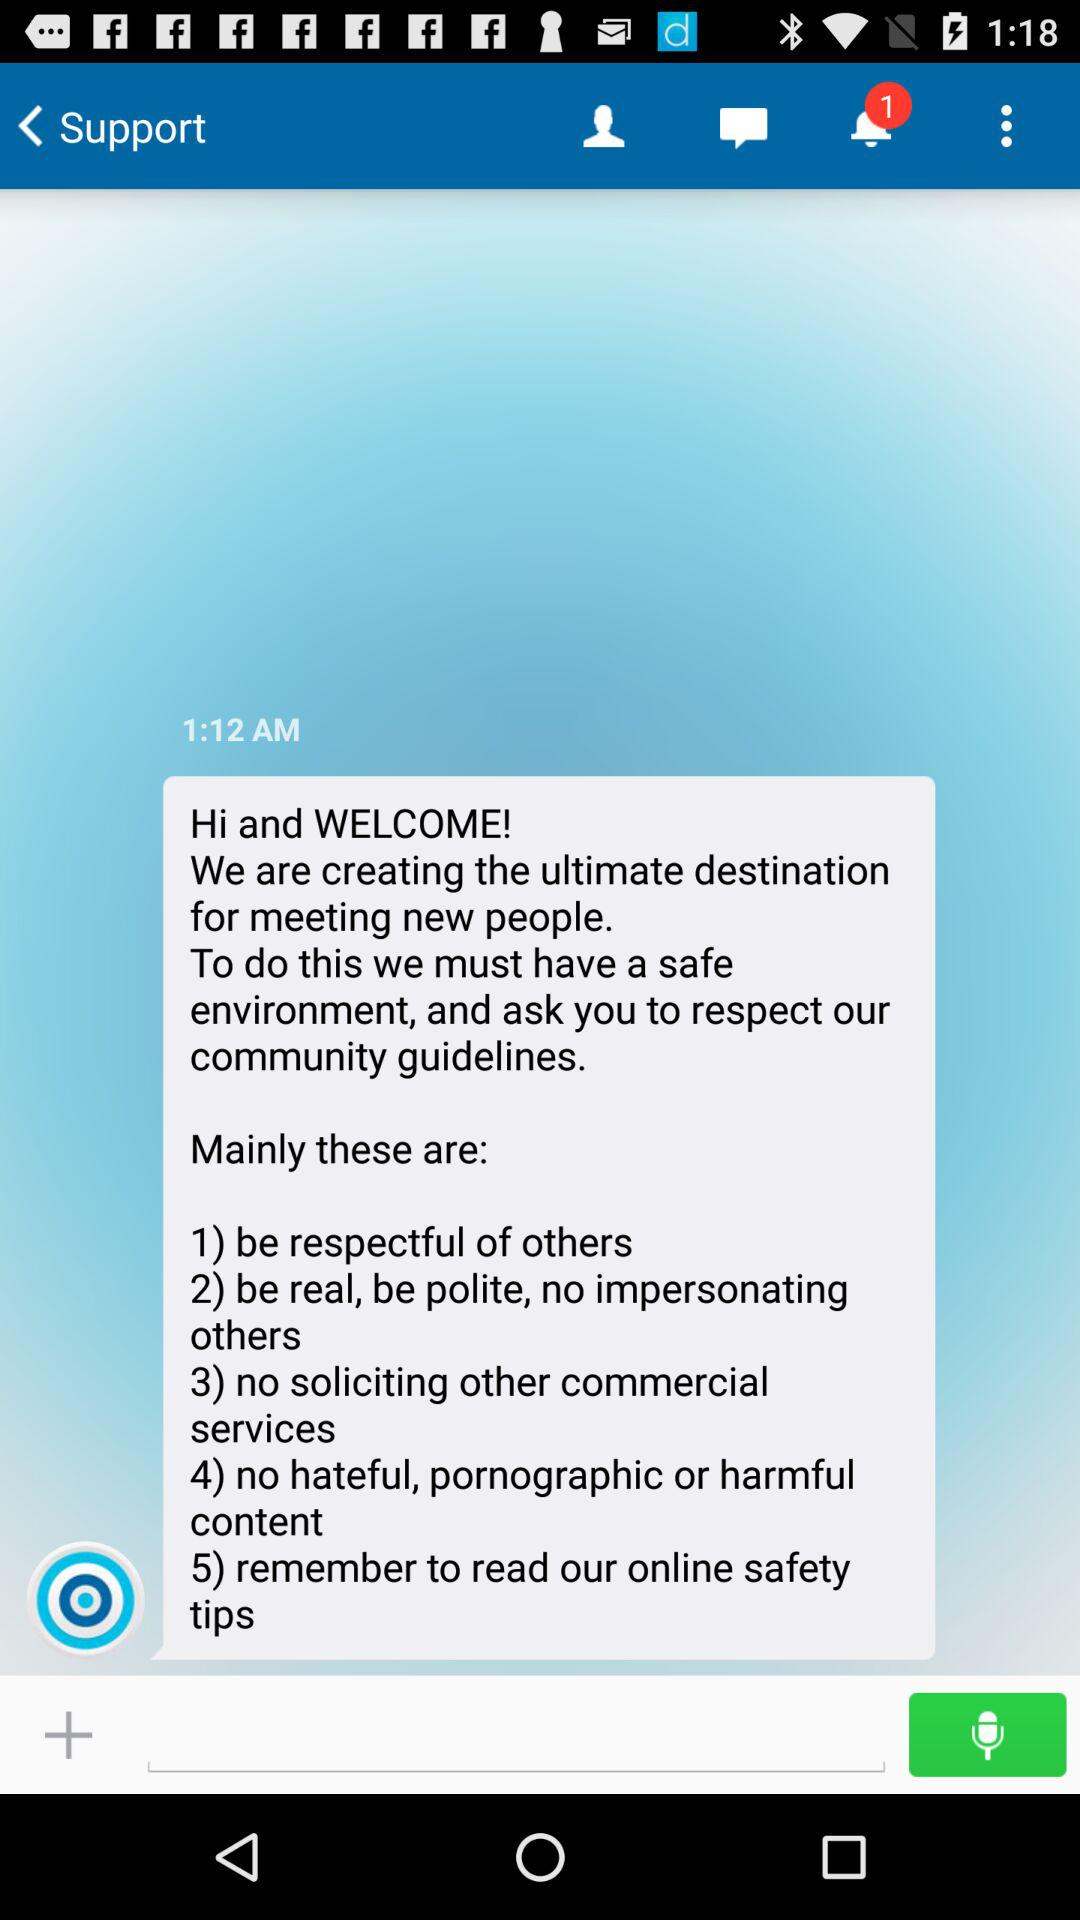How many guidelines are there?
Answer the question using a single word or phrase. 5 